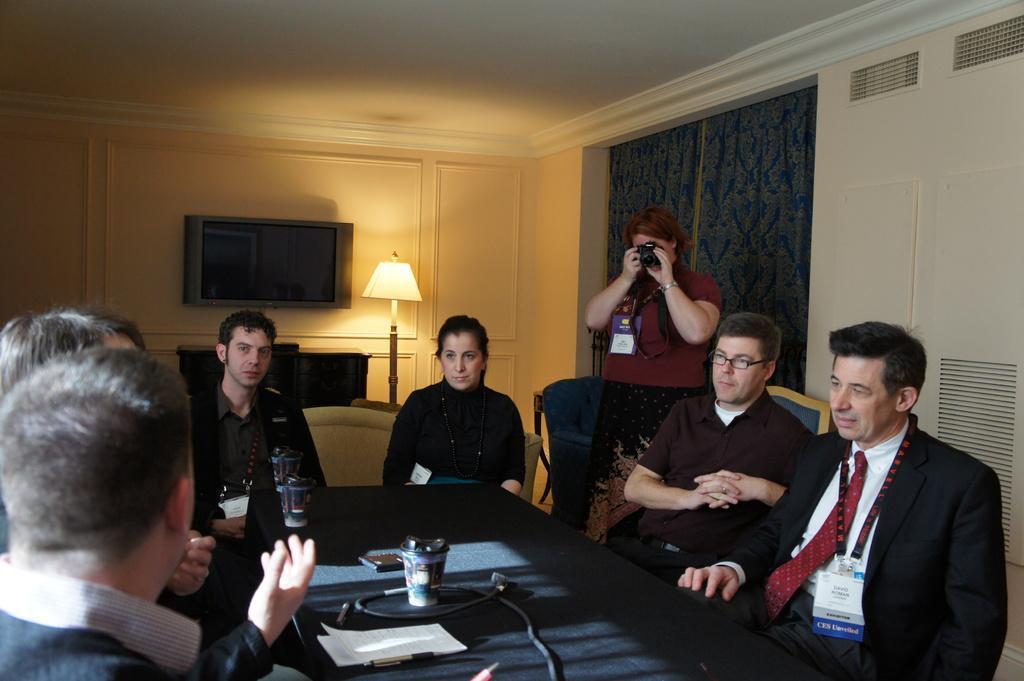In one or two sentences, can you explain what this image depicts? There are persons in different color dresses, sitting on chairs, around the table, on which, there are glasses, papers, pen, cable, mobile and other objects. In the background, there is a person, holding a camera and capturing a photo, there is a monitor on the wall, there is a light on the table, there is a window, which is having a curtain, white color ceiling and other objects. 